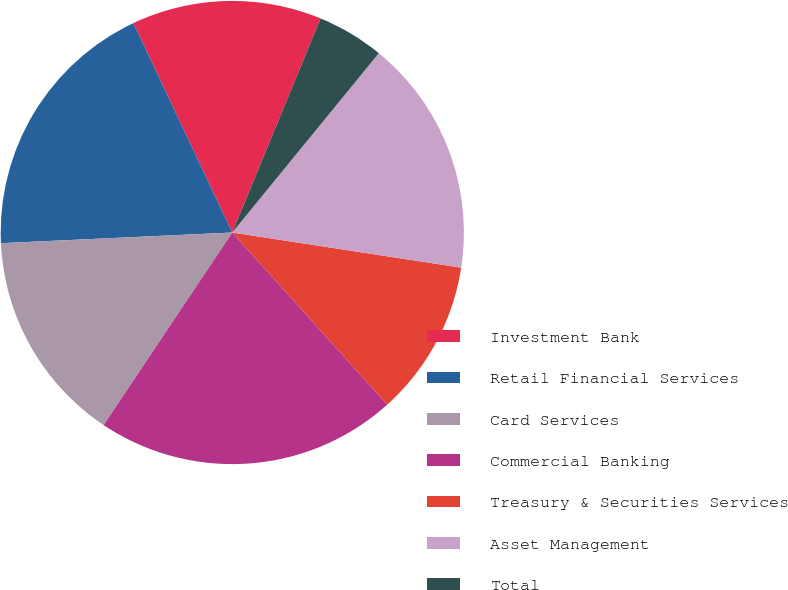Convert chart. <chart><loc_0><loc_0><loc_500><loc_500><pie_chart><fcel>Investment Bank<fcel>Retail Financial Services<fcel>Card Services<fcel>Commercial Banking<fcel>Treasury & Securities Services<fcel>Asset Management<fcel>Total<nl><fcel>13.25%<fcel>18.71%<fcel>14.89%<fcel>21.04%<fcel>10.91%<fcel>16.52%<fcel>4.68%<nl></chart> 